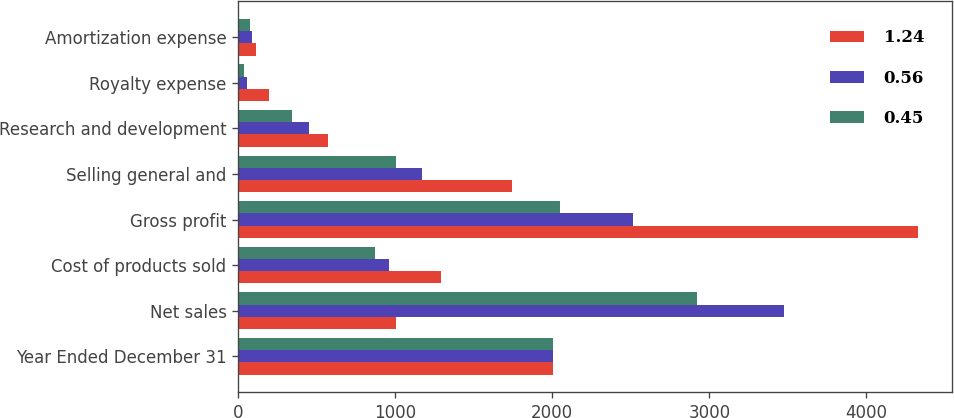Convert chart. <chart><loc_0><loc_0><loc_500><loc_500><stacked_bar_chart><ecel><fcel>Year Ended December 31<fcel>Net sales<fcel>Cost of products sold<fcel>Gross profit<fcel>Selling general and<fcel>Research and development<fcel>Royalty expense<fcel>Amortization expense<nl><fcel>1.24<fcel>2004<fcel>1002<fcel>1292<fcel>4332<fcel>1742<fcel>569<fcel>195<fcel>112<nl><fcel>0.56<fcel>2003<fcel>3476<fcel>961<fcel>2515<fcel>1171<fcel>452<fcel>54<fcel>89<nl><fcel>0.45<fcel>2002<fcel>2919<fcel>870<fcel>2049<fcel>1002<fcel>343<fcel>36<fcel>72<nl></chart> 